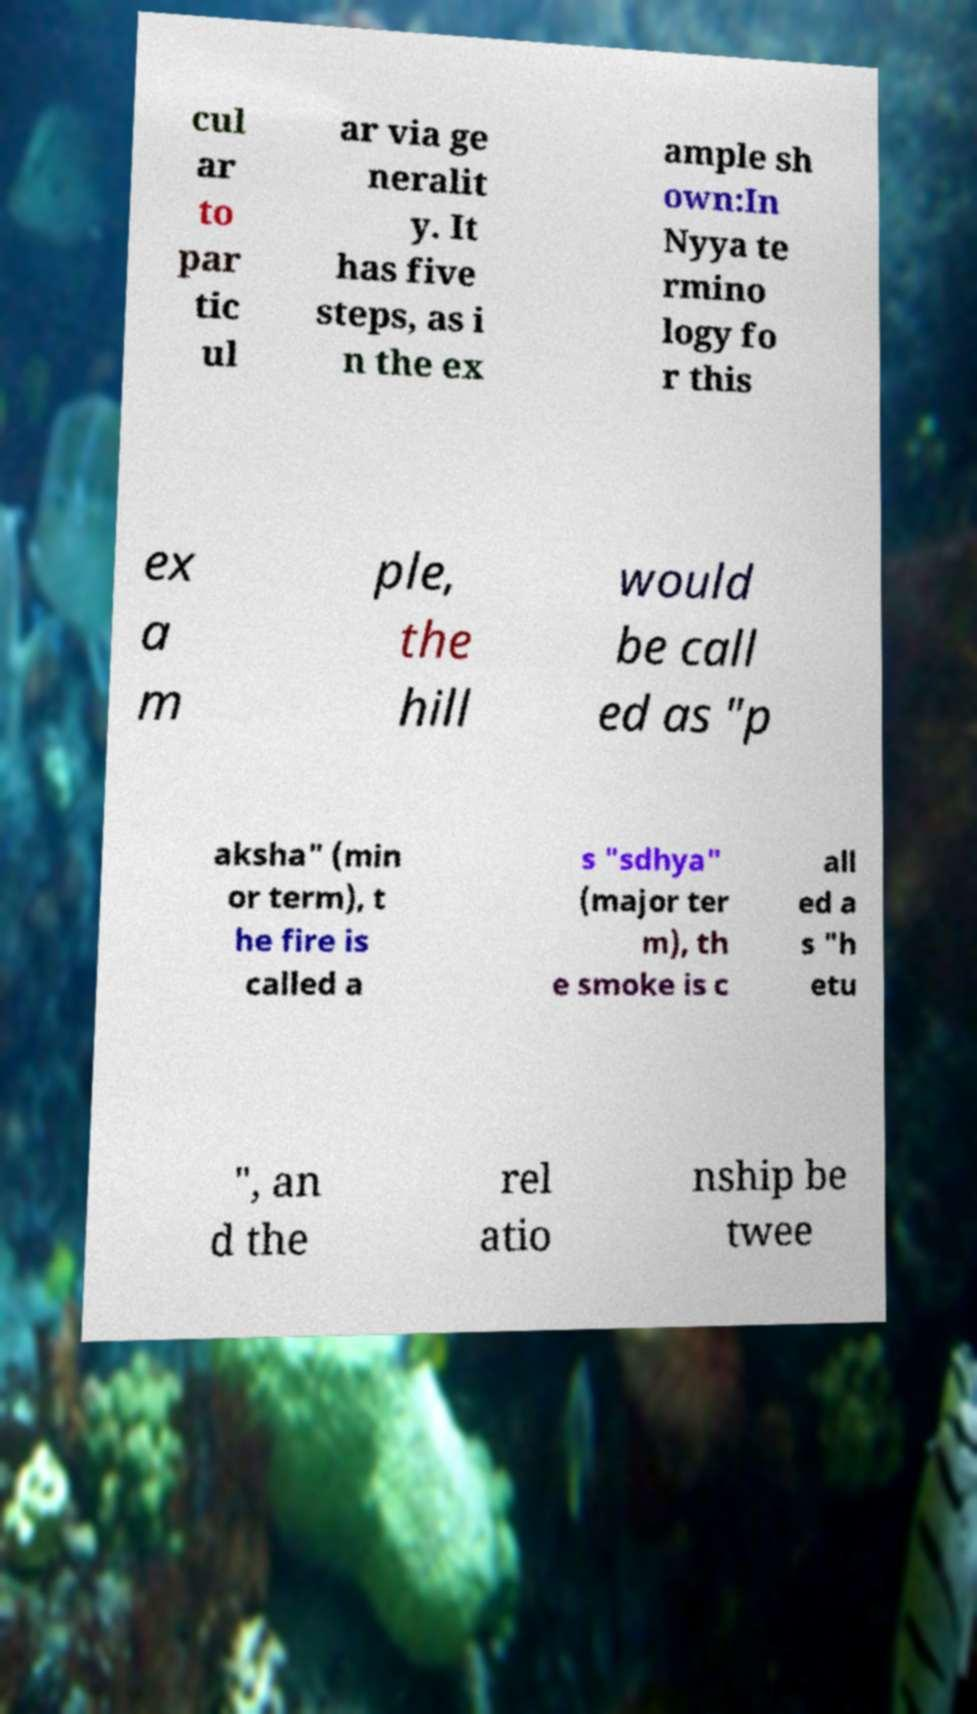What messages or text are displayed in this image? I need them in a readable, typed format. cul ar to par tic ul ar via ge neralit y. It has five steps, as i n the ex ample sh own:In Nyya te rmino logy fo r this ex a m ple, the hill would be call ed as "p aksha" (min or term), t he fire is called a s "sdhya" (major ter m), th e smoke is c all ed a s "h etu ", an d the rel atio nship be twee 